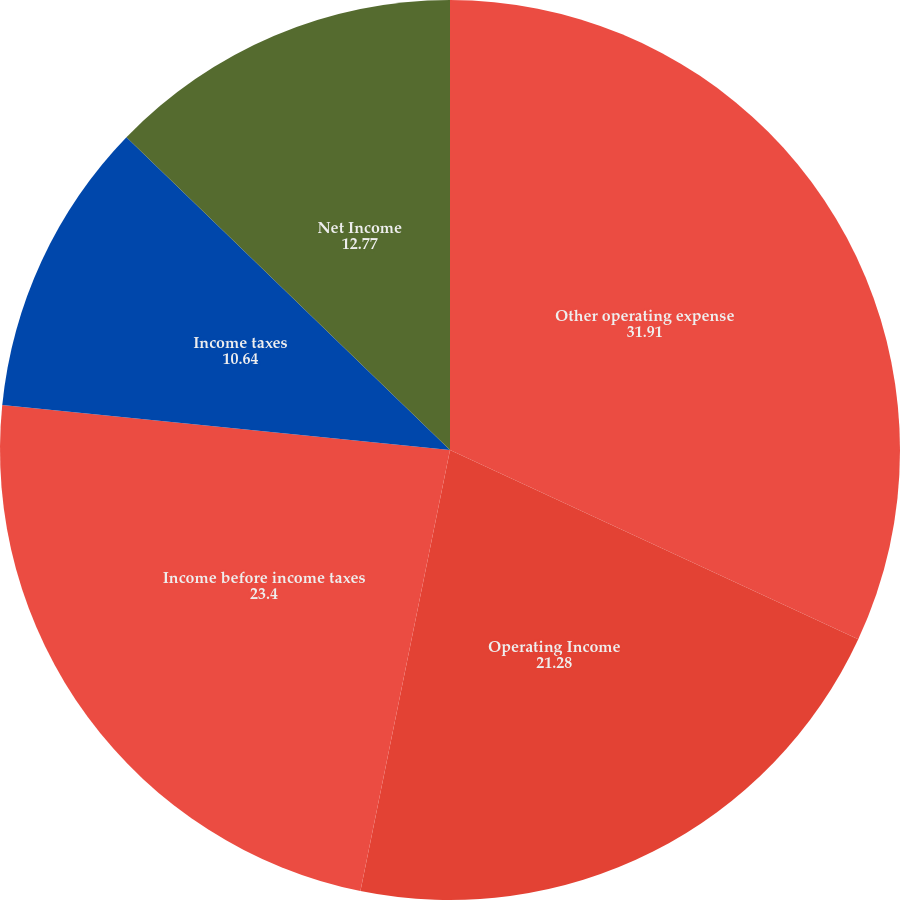Convert chart. <chart><loc_0><loc_0><loc_500><loc_500><pie_chart><fcel>Other operating expense<fcel>Operating Income<fcel>Income before income taxes<fcel>Income taxes<fcel>Net Income<nl><fcel>31.91%<fcel>21.28%<fcel>23.4%<fcel>10.64%<fcel>12.77%<nl></chart> 